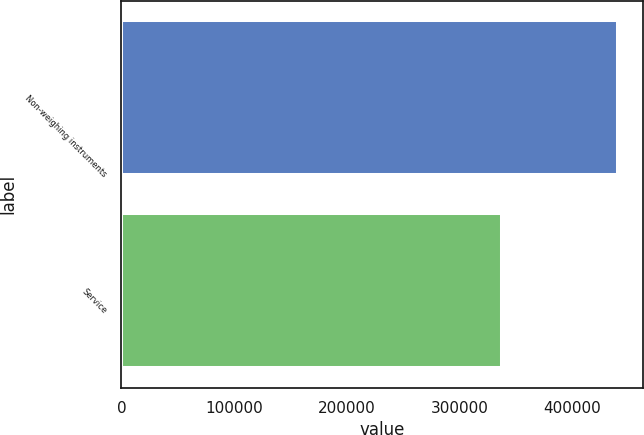Convert chart. <chart><loc_0><loc_0><loc_500><loc_500><bar_chart><fcel>Non-weighing instruments<fcel>Service<nl><fcel>440728<fcel>338163<nl></chart> 